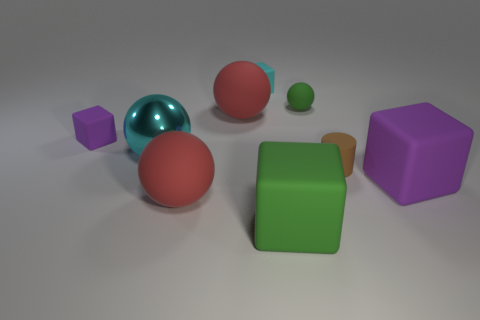What number of big matte blocks have the same color as the small rubber ball?
Your answer should be compact. 1. Is the number of tiny brown cylinders behind the cyan cube the same as the number of cyan objects behind the green sphere?
Your answer should be very brief. No. What number of purple things are large matte objects or metal spheres?
Offer a very short reply. 1. Is the color of the big metal object the same as the matte thing behind the tiny ball?
Offer a terse response. Yes. How many other objects are the same color as the metallic ball?
Provide a succinct answer. 1. Are there fewer big blocks than cubes?
Keep it short and to the point. Yes. There is a purple thing behind the large cube behind the big green matte object; how many tiny things are in front of it?
Offer a very short reply. 1. What is the size of the purple matte cube to the right of the cyan matte thing?
Provide a short and direct response. Large. Is the shape of the red thing that is in front of the large purple block the same as  the tiny cyan object?
Your answer should be very brief. No. What material is the large cyan thing that is the same shape as the tiny green object?
Provide a short and direct response. Metal. 